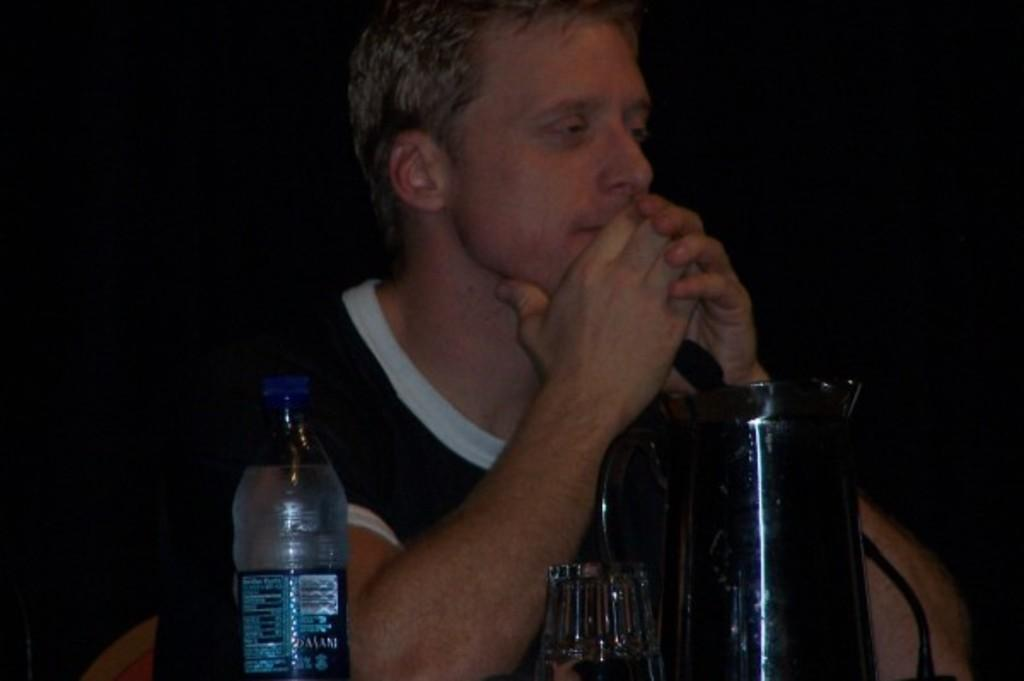What is the main subject of the image? The main subject of the image is a man. What is the man doing in the image? The man is sitting on a chair in the image. What object is the man positioned behind? The man is behind a jar in the image. What other object can be seen in the image? There is a water bottle in the image. What type of veil is draped over the man's finger in the image? There is no veil or finger present in the image. How many sides does the square-shaped object have in the image? There is no square-shaped object present in the image. 